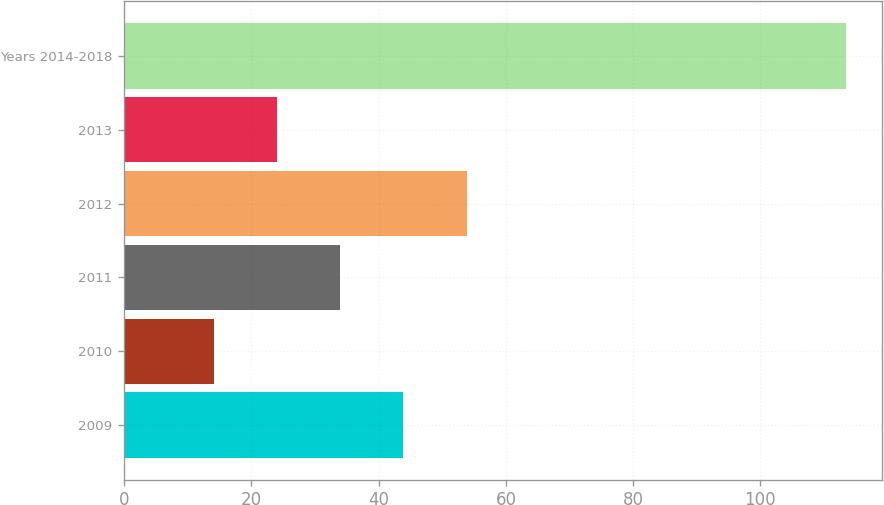Convert chart to OTSL. <chart><loc_0><loc_0><loc_500><loc_500><bar_chart><fcel>2009<fcel>2010<fcel>2011<fcel>2012<fcel>2013<fcel>Years 2014-2018<nl><fcel>43.89<fcel>14.1<fcel>33.96<fcel>53.82<fcel>24.03<fcel>113.4<nl></chart> 